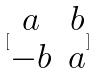Convert formula to latex. <formula><loc_0><loc_0><loc_500><loc_500>[ \begin{matrix} a & b \\ - b & a \end{matrix} ]</formula> 